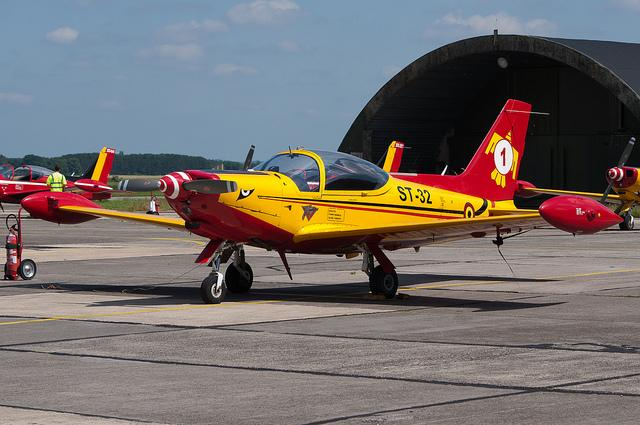What is the purpose of the black structure? store planes 